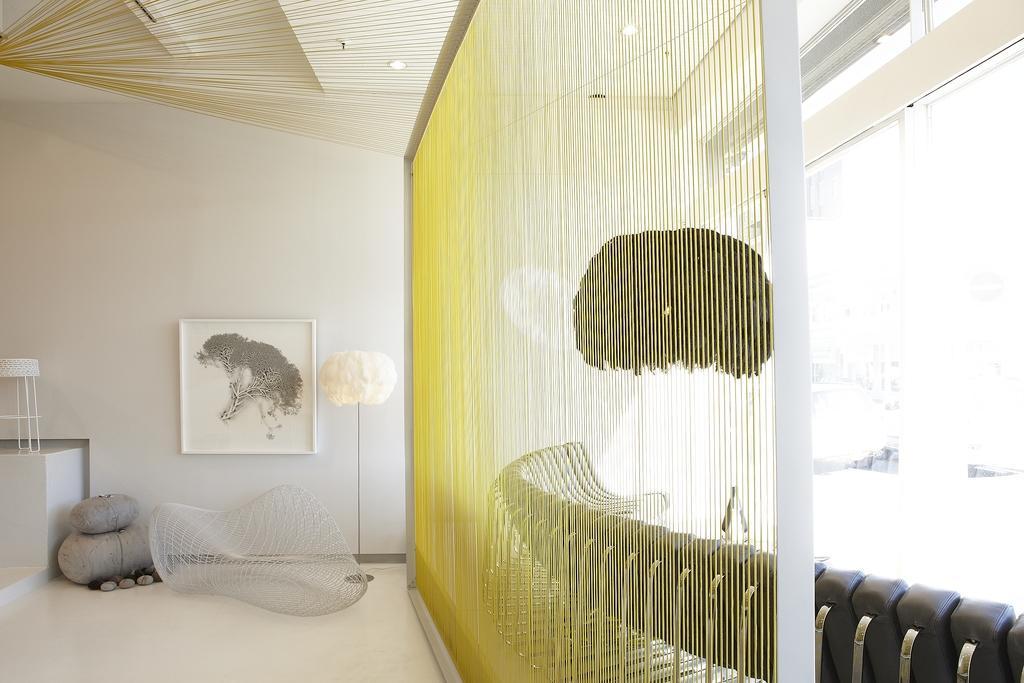Describe this image in one or two sentences. This image is taken in the room. In the center of the image there is a couch. On the right we can see a sofa and there is a curtain. We can see a lamp. In the background there is a frame placed on the wall. We can see stones. There is a stool. At the top there are lights. 